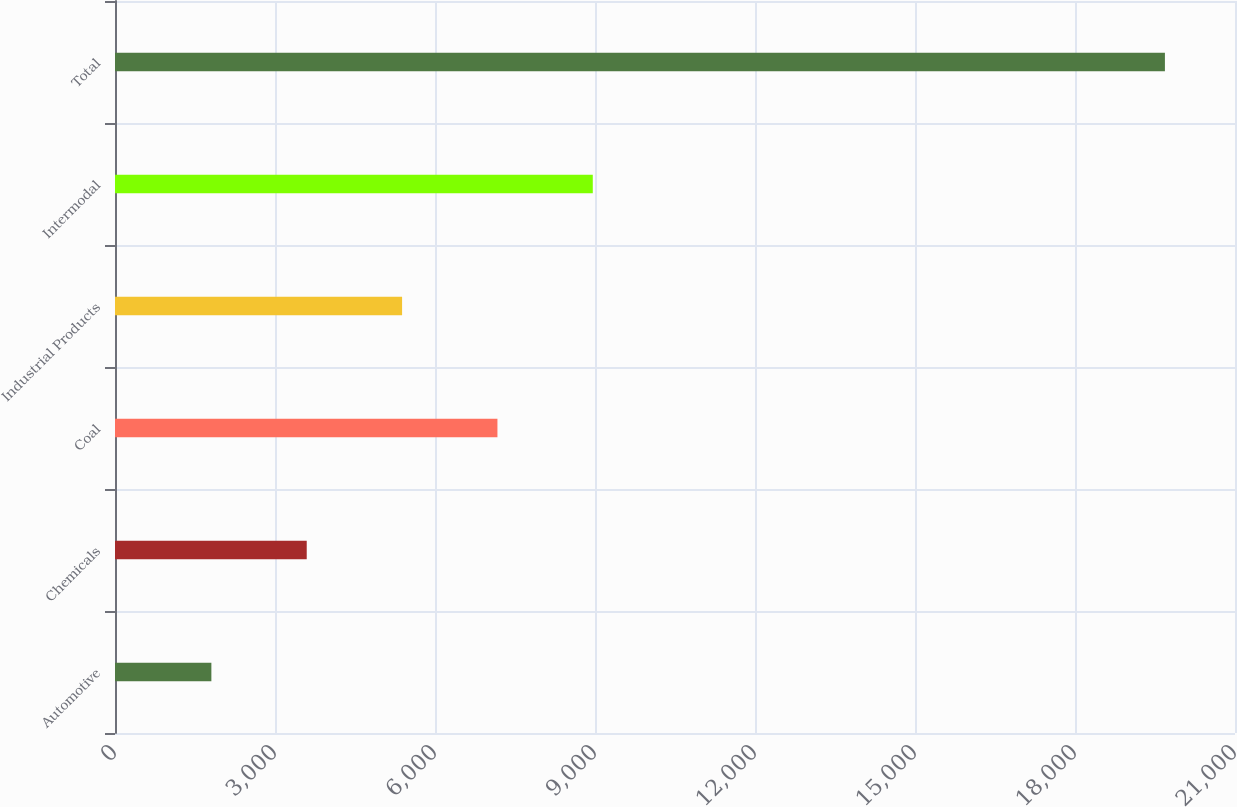<chart> <loc_0><loc_0><loc_500><loc_500><bar_chart><fcel>Automotive<fcel>Chemicals<fcel>Coal<fcel>Industrial Products<fcel>Intermodal<fcel>Total<nl><fcel>1807<fcel>3594.9<fcel>7170.7<fcel>5382.8<fcel>8958.6<fcel>19686<nl></chart> 